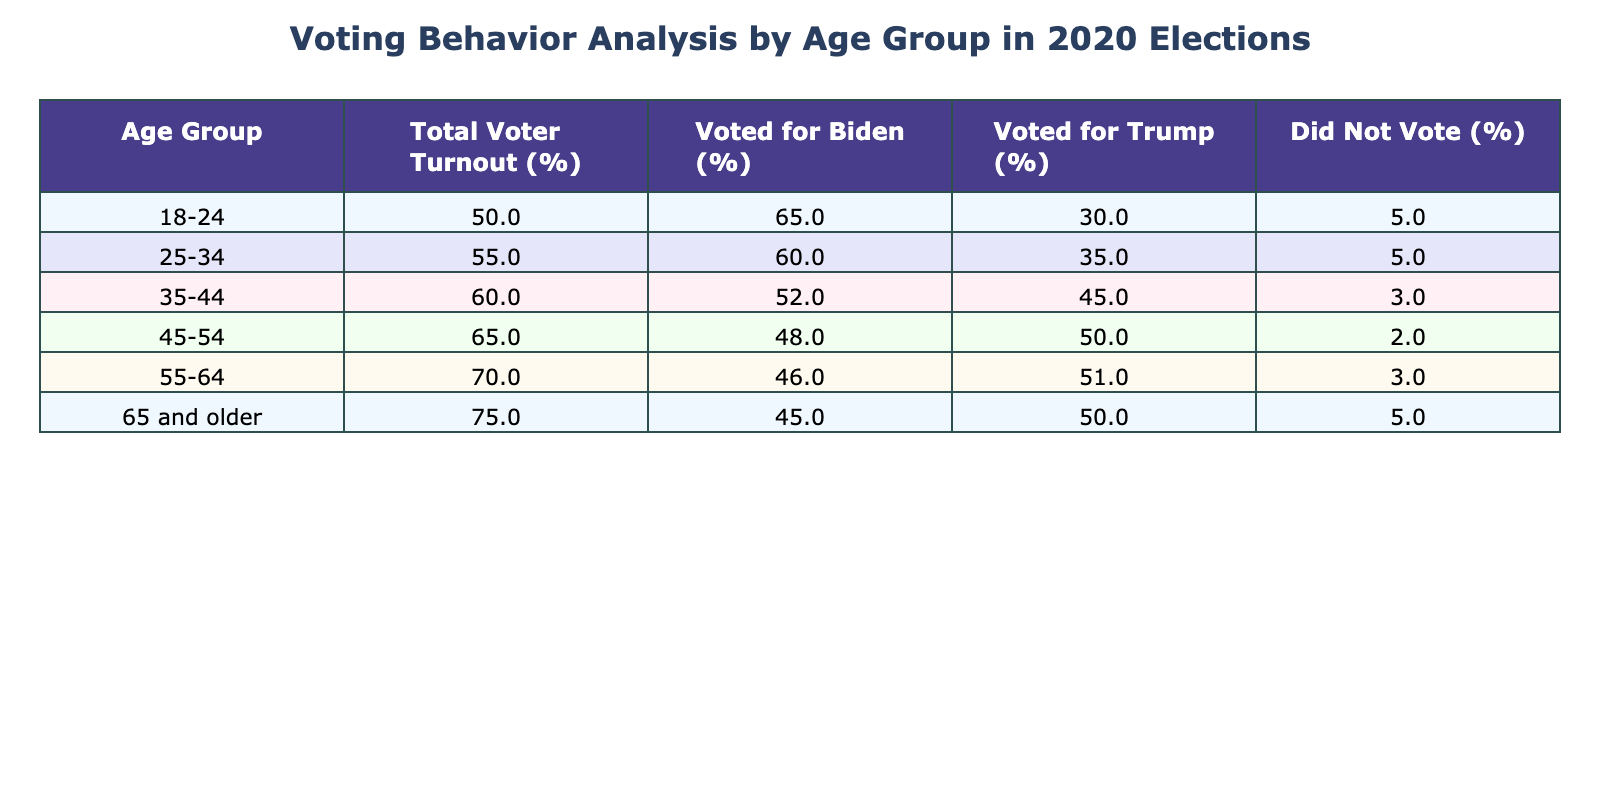What is the total voter turnout for the 45-54 age group? The table shows that the total voter turnout for the 45-54 age group is 65%. This value can be directly retrieved from the corresponding row in the table.
Answer: 65% Which age group had the highest percentage of voters who did not vote? The highest percentage of those who did not vote can be found by comparing the "Did Not Vote (%)" column across all age groups. The 35-44, 45-54, 55-64, and 65 and older groups all show a 3% vote turnout, but the 45-54 and 65+ groups have 2% and 5% respectively—confirming the highest value is 5% in the 18-24 and 25-34 groups.
Answer: 5% What percentage of voters aged 18-24 voted for Biden? From the table, the percentage of 18-24 voters who voted for Biden is 65%. This is directly found in the "Voted for Biden (%)" column for that age group.
Answer: 65% What is the average percentage of voters who voted for Trump across all age groups? To find the average, we sum the percentages of Trump votes for each age group: (30 + 35 + 45 + 50 + 51 + 50) = 261. There are 6 age groups, so the average is 261 / 6 = 43.5%.
Answer: 43.5% Did more voters in the 25-34 age group vote for Biden or Trump? In the 25-34 age group, 60% voted for Biden, while 35% voted for Trump. Therefore, we compare these percentages directly: 60% > 35%, which indicates that more voters chose Biden.
Answer: Yes What is the difference in voter turnout between the youngest age group (18-24) and the oldest age group (65 and older)? The total voter turnout for 18-24 is 50%, and for 65 and older, it is 75%. To find the difference, we subtract the younger group's turnout from the older group's: 75% - 50% = 25%.
Answer: 25% Which age group had the lowest percentage of voters who voted for Biden? By examining the "Voted for Biden (%)" column, we see that the lowest percentage of voters who chose Biden is 45%, which corresponds to the 65 and older age group.
Answer: 45% If we combine the voter turnout percentages for the 35-44 and 45-54 age groups, what is their total? The voter turnout for 35-44 is 60% and for 45-54 is 65%. To find the combined total, we add these percentages together: 60% + 65% = 125%.
Answer: 125% Is the percentage of 55-64 year-olds who voted for Trump greater than the percentage of 45-54 year-olds who voted for Trump? According to the table, 55-64 year-olds voted for Trump at 51%, while 45-54 year-olds voted for Trump at 50%. Thus, 51% > 50%, confirming that the statement is true.
Answer: Yes What percentage of the 25-34 age group did not vote? The table indicates a 5% turnout for the 25-34 age group in the "Did Not Vote (%)" column, which can be directly retrieved from the table.
Answer: 5% What is the trend in the voting behavior for Biden as age increases? By reviewing the "Voted for Biden (%)" column, we observe a decreasing trend: 65% (18-24), 60% (25-34), 52% (35-44), 48% (45-54), 46% (55-64), and 45% (65 and older). This indicates a decline in Biden’s voter support with increasing age.
Answer: Decreasing trend 